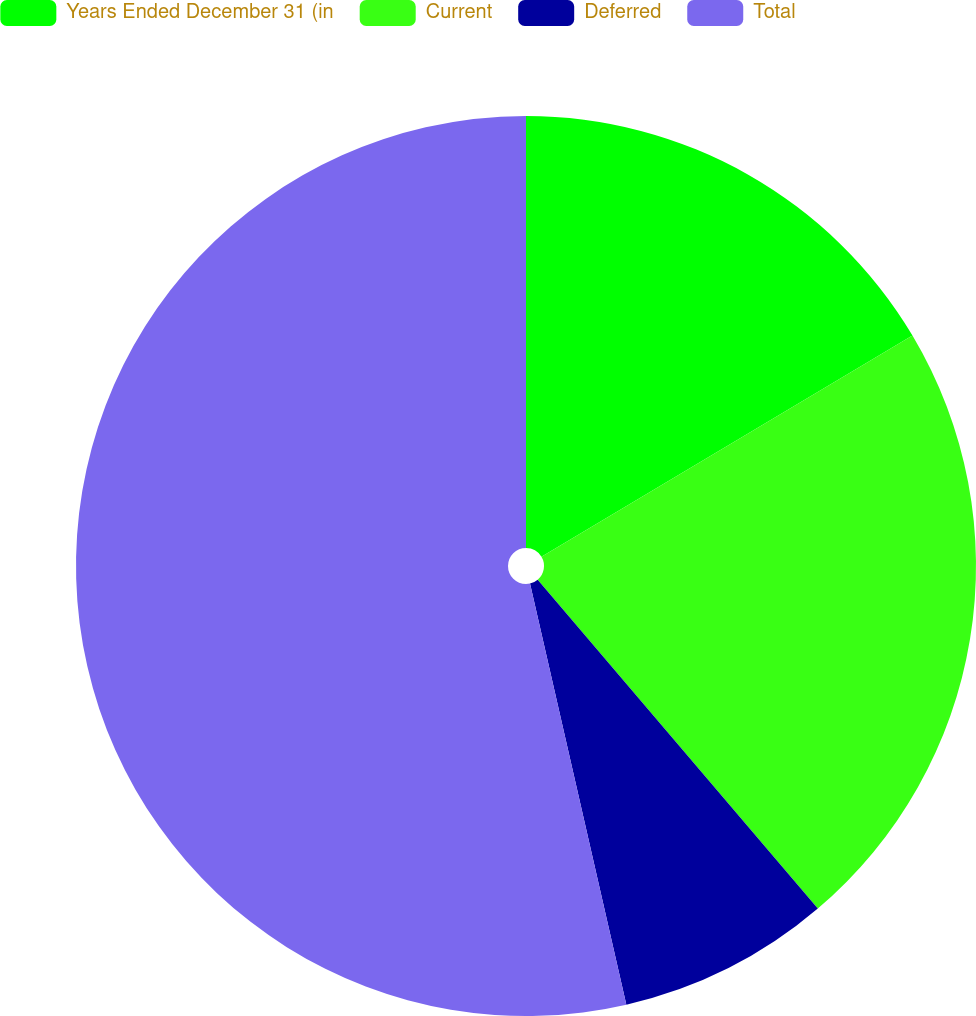Convert chart. <chart><loc_0><loc_0><loc_500><loc_500><pie_chart><fcel>Years Ended December 31 (in<fcel>Current<fcel>Deferred<fcel>Total<nl><fcel>16.44%<fcel>22.33%<fcel>7.65%<fcel>53.58%<nl></chart> 